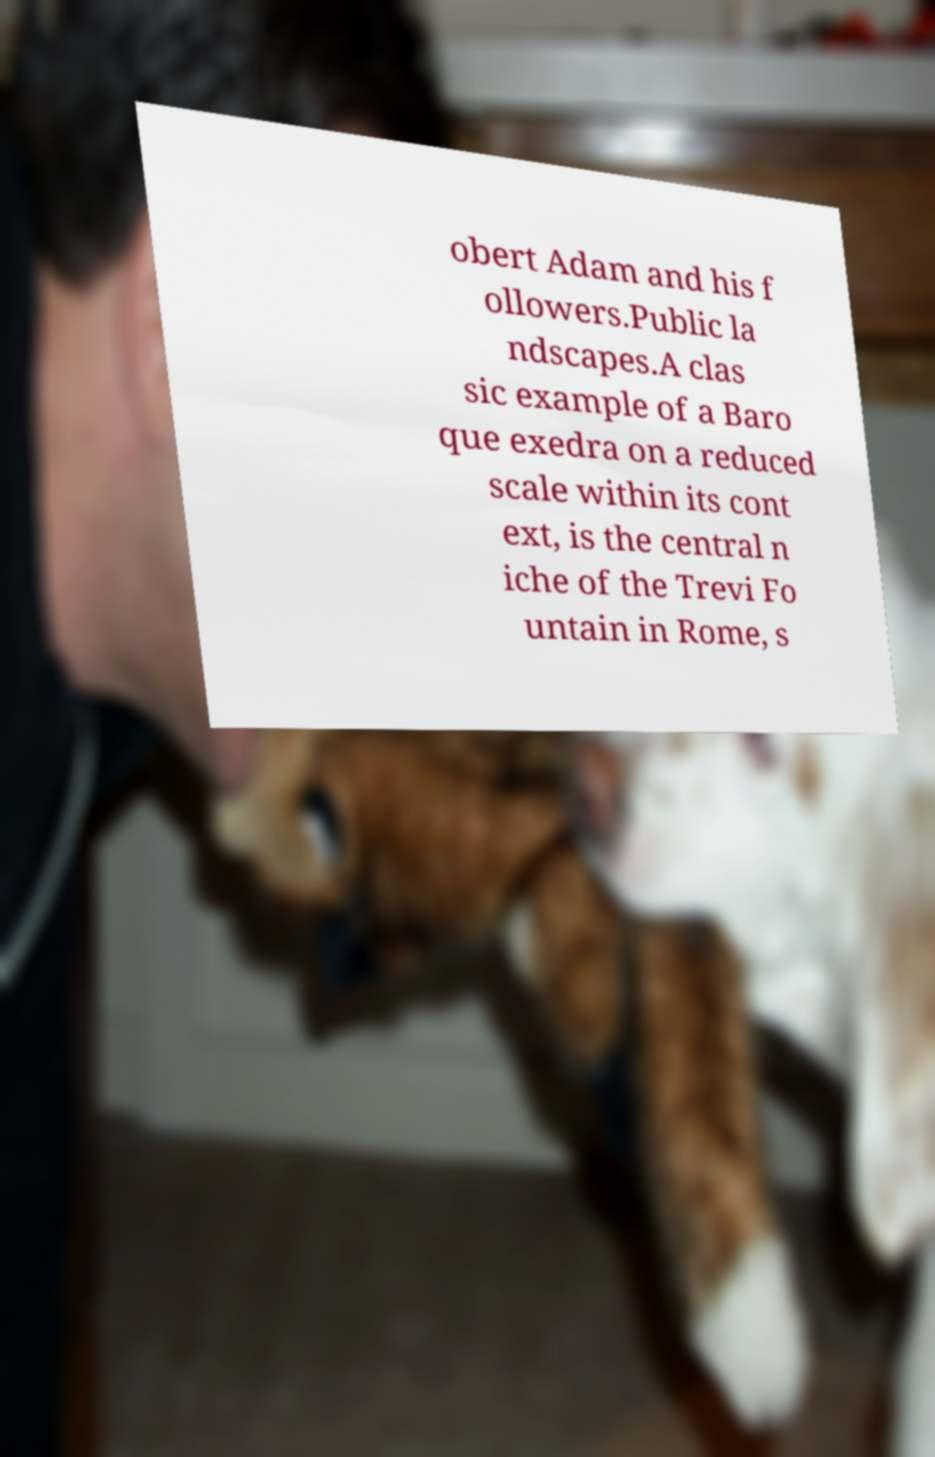Please read and relay the text visible in this image. What does it say? obert Adam and his f ollowers.Public la ndscapes.A clas sic example of a Baro que exedra on a reduced scale within its cont ext, is the central n iche of the Trevi Fo untain in Rome, s 